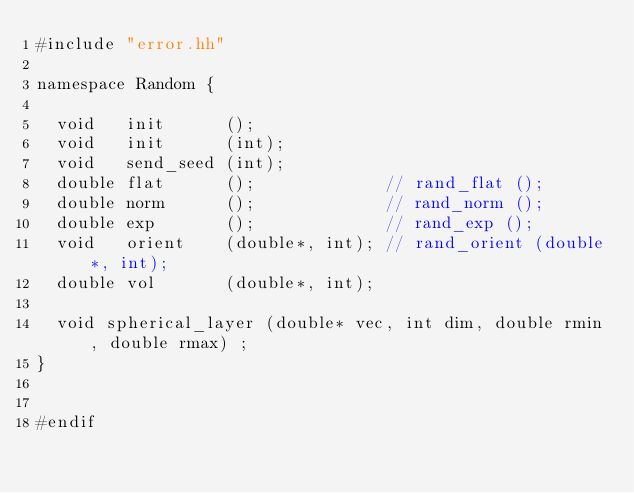<code> <loc_0><loc_0><loc_500><loc_500><_C++_>#include "error.hh"

namespace Random {

  void   init      ();
  void   init      (int);
  void   send_seed (int);
  double flat      ();             // rand_flat ();
  double norm      ();             // rand_norm ();
  double exp       ();             // rand_exp ();
  void   orient    (double*, int); // rand_orient (double*, int);
  double vol       (double*, int); 

  void spherical_layer (double* vec, int dim, double rmin, double rmax) ;
}


#endif
</code> 